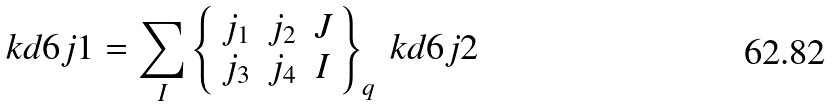<formula> <loc_0><loc_0><loc_500><loc_500>\ k d { 6 j 1 } = \sum _ { I } \left \{ \begin{array} { c c c } j _ { 1 } & j _ { 2 } & J \\ j _ { 3 } & j _ { 4 } & I \end{array} \right \} _ { q } \ k d { 6 j 2 }</formula> 